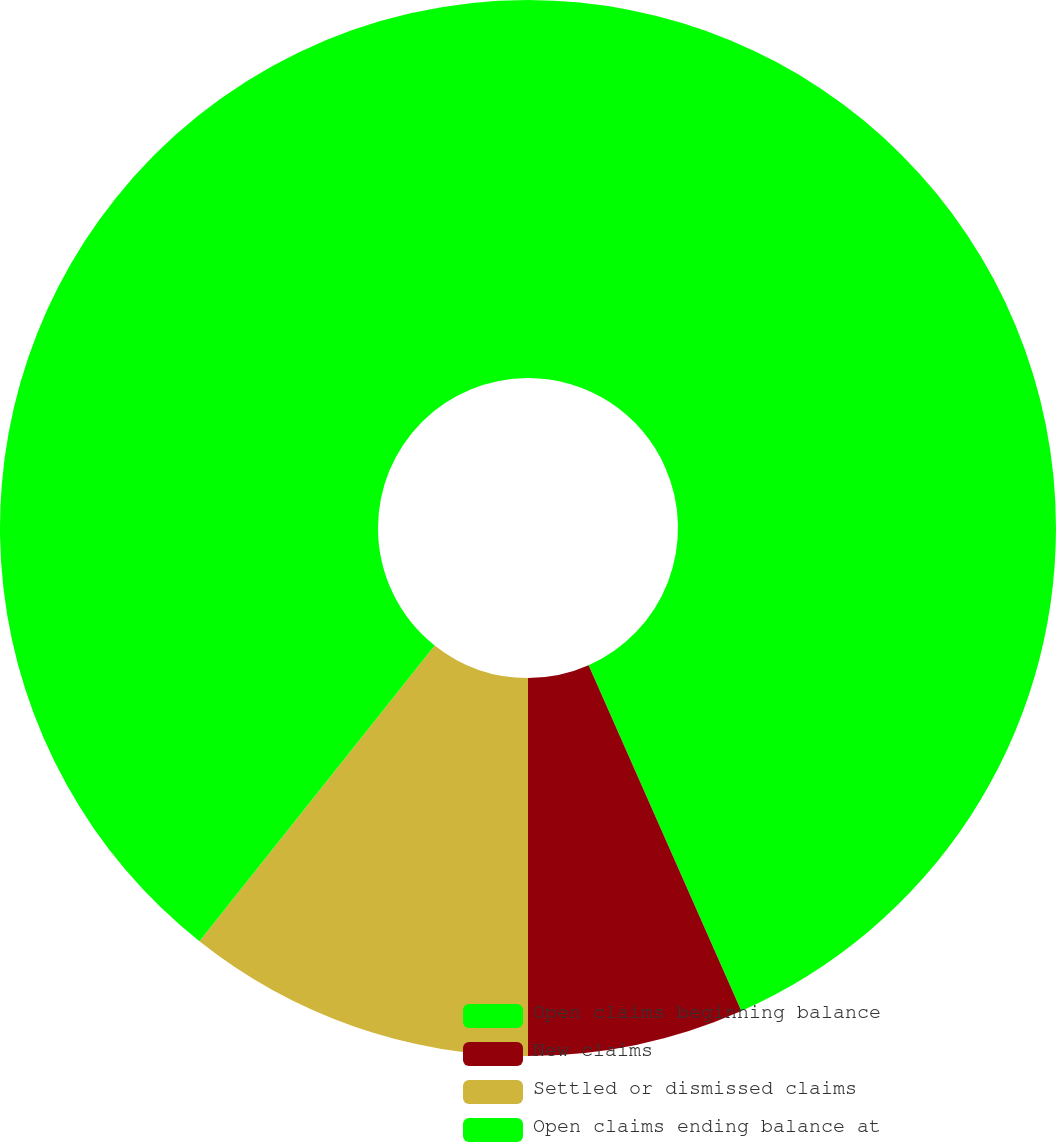Convert chart. <chart><loc_0><loc_0><loc_500><loc_500><pie_chart><fcel>Open claims beginning balance<fcel>New claims<fcel>Settled or dismissed claims<fcel>Open claims ending balance at<nl><fcel>43.38%<fcel>6.62%<fcel>10.69%<fcel>39.31%<nl></chart> 